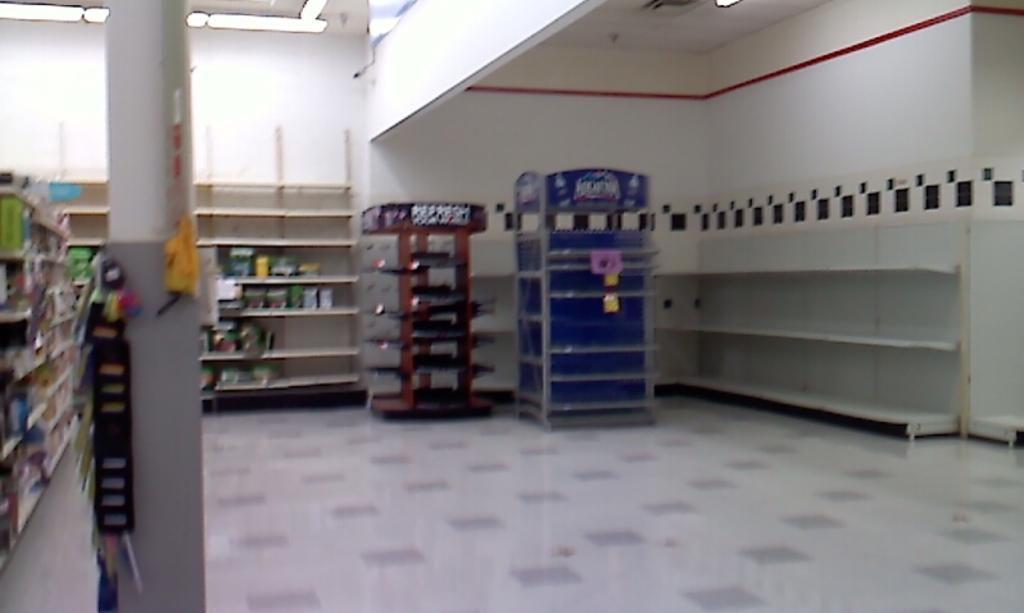<image>
Relay a brief, clear account of the picture shown. A large room has a blue cart in it that is filled with Aquafina. 